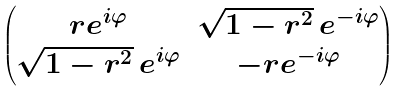Convert formula to latex. <formula><loc_0><loc_0><loc_500><loc_500>\begin{pmatrix} r e ^ { i \varphi } & \sqrt { 1 - r ^ { 2 } } \, e ^ { - i \varphi } \\ \sqrt { 1 - r ^ { 2 } } \, e ^ { i \varphi } & - r e ^ { - i \varphi } \end{pmatrix}</formula> 